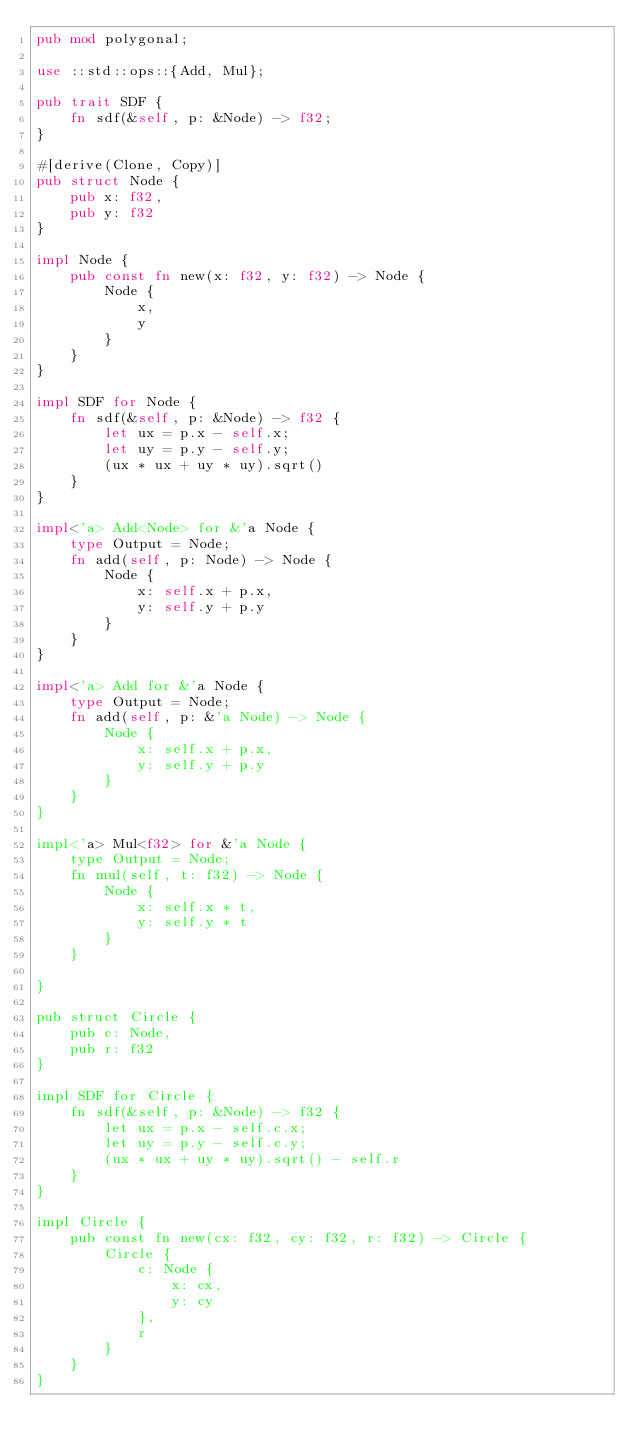<code> <loc_0><loc_0><loc_500><loc_500><_Rust_>pub mod polygonal;

use ::std::ops::{Add, Mul};

pub trait SDF {
    fn sdf(&self, p: &Node) -> f32;
}

#[derive(Clone, Copy)]
pub struct Node {
    pub x: f32,
    pub y: f32
}

impl Node {
    pub const fn new(x: f32, y: f32) -> Node {
        Node {
            x,
            y
        }
    }
}

impl SDF for Node {
    fn sdf(&self, p: &Node) -> f32 {
        let ux = p.x - self.x;
        let uy = p.y - self.y;
        (ux * ux + uy * uy).sqrt()
    }
}

impl<'a> Add<Node> for &'a Node {
    type Output = Node;
    fn add(self, p: Node) -> Node {
        Node {
            x: self.x + p.x,
            y: self.y + p.y
        }
    }
}

impl<'a> Add for &'a Node {
    type Output = Node;
    fn add(self, p: &'a Node) -> Node {
        Node {
            x: self.x + p.x,
            y: self.y + p.y
        }
    }
}

impl<'a> Mul<f32> for &'a Node {
    type Output = Node;
    fn mul(self, t: f32) -> Node {
        Node {
            x: self.x * t,
            y: self.y * t
        }
    }

}

pub struct Circle {
    pub c: Node,
    pub r: f32
}

impl SDF for Circle {
    fn sdf(&self, p: &Node) -> f32 {
        let ux = p.x - self.c.x;
        let uy = p.y - self.c.y;
        (ux * ux + uy * uy).sqrt() - self.r
    }
}

impl Circle {
    pub const fn new(cx: f32, cy: f32, r: f32) -> Circle {
        Circle {
            c: Node {
                x: cx,
                y: cy
            },
            r
        }
    }
}
</code> 